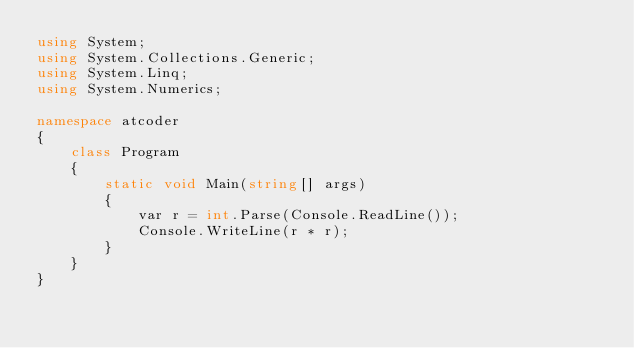<code> <loc_0><loc_0><loc_500><loc_500><_C#_>using System;
using System.Collections.Generic;
using System.Linq;
using System.Numerics;

namespace atcoder
{
    class Program
    {
        static void Main(string[] args)
        {
            var r = int.Parse(Console.ReadLine());
            Console.WriteLine(r * r);
        }
    }
}</code> 